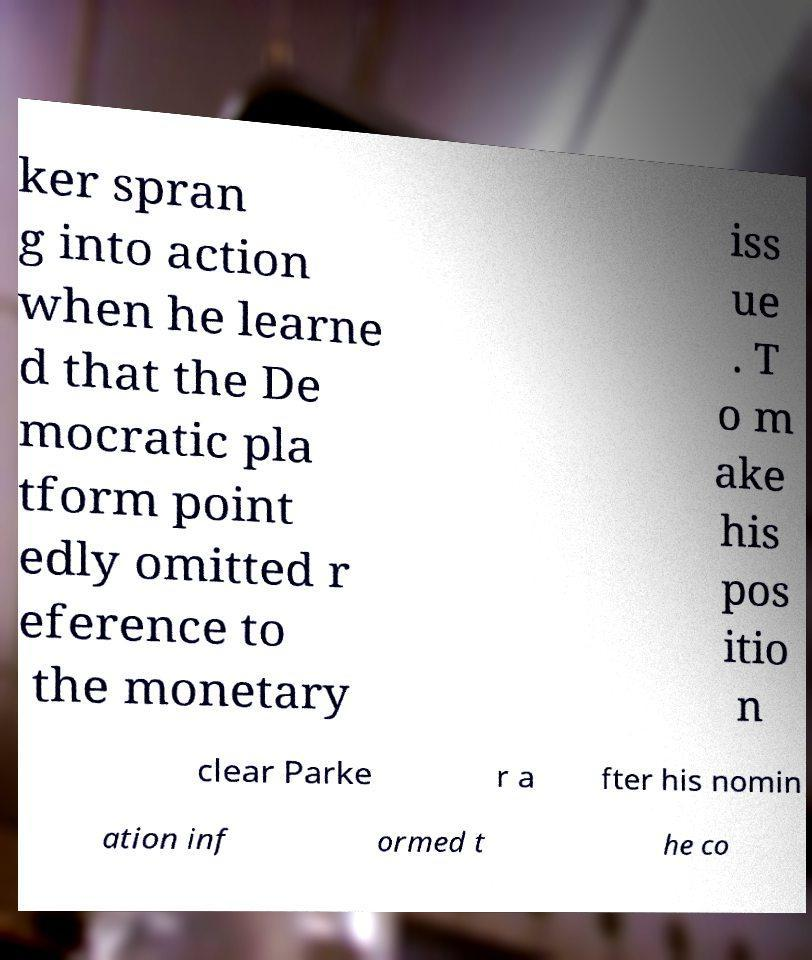For documentation purposes, I need the text within this image transcribed. Could you provide that? ker spran g into action when he learne d that the De mocratic pla tform point edly omitted r eference to the monetary iss ue . T o m ake his pos itio n clear Parke r a fter his nomin ation inf ormed t he co 